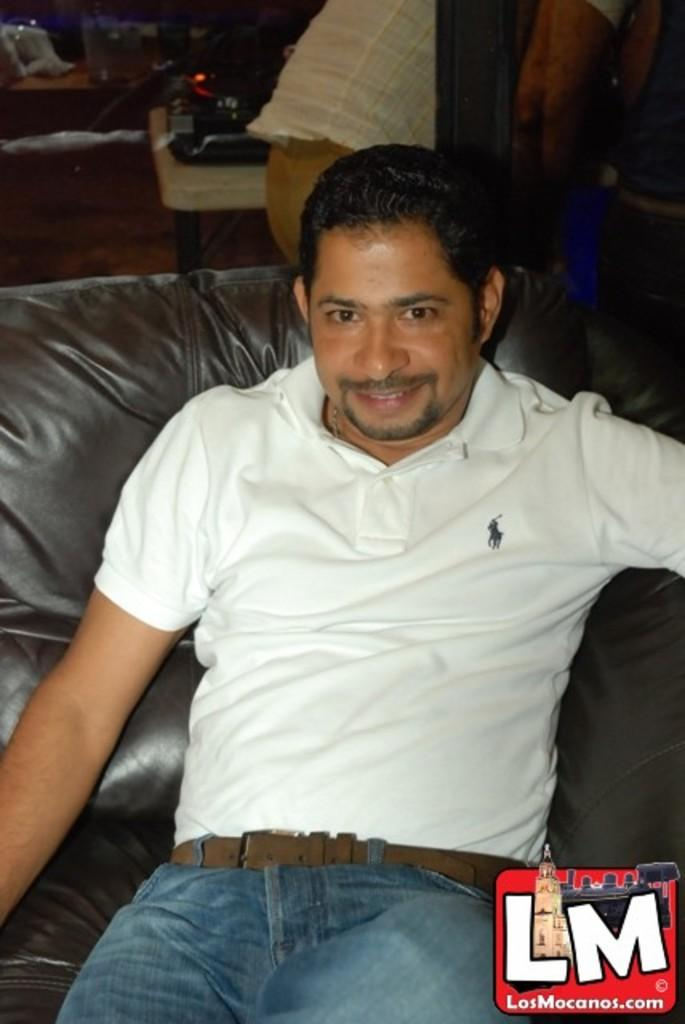How many people are in the image? There are people in the image, but the exact number is not specified. What is the position of one of the people in the image? One person is sitting on a sofa. Can you describe the background of the image? There are objects visible in the background of the image. What is located at the bottom of the image? There is a logo at the bottom of the image. What type of prose can be seen on the sofa in the image? There is no prose visible on the sofa or anywhere else in the image. Is there a toy present on the sofa in the image? There is no toy visible on the sofa or anywhere else in the image. 